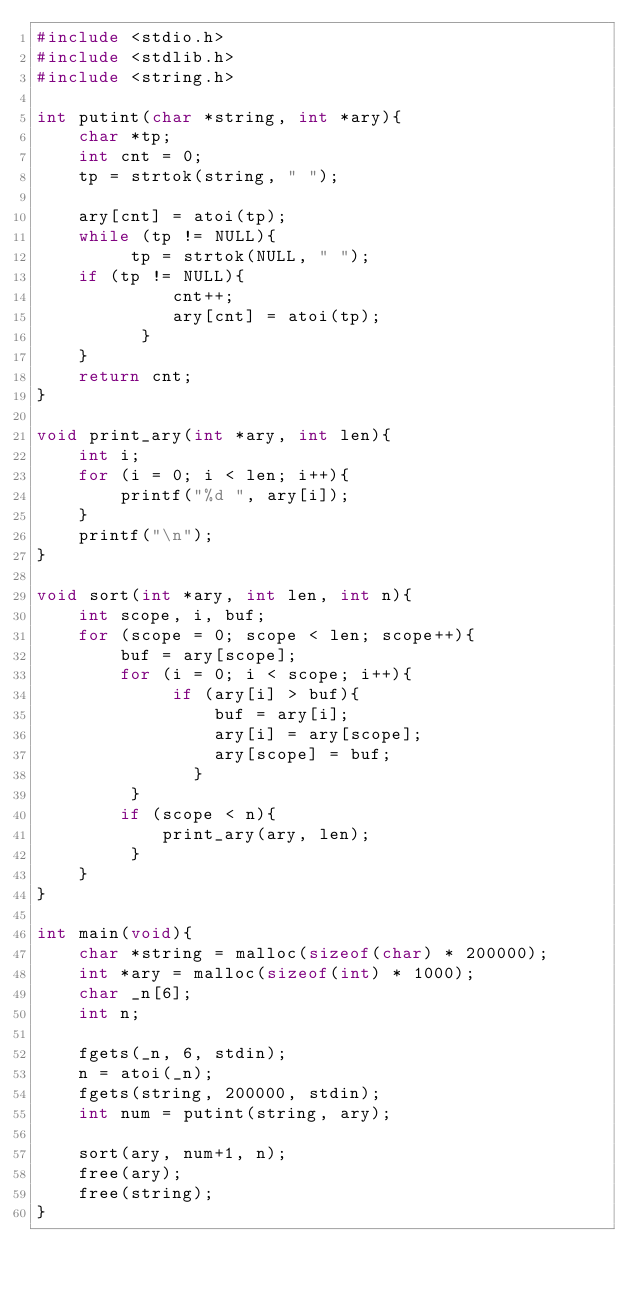<code> <loc_0><loc_0><loc_500><loc_500><_C_>#include <stdio.h>
#include <stdlib.h>
#include <string.h>

int putint(char *string, int *ary){
    char *tp;
    int cnt = 0;
    tp = strtok(string, " ");
    
    ary[cnt] = atoi(tp);
    while (tp != NULL){
         tp = strtok(NULL, " ");
	  if (tp != NULL){
             cnt++;
             ary[cnt] = atoi(tp);  
          }
    }
    return cnt;
}

void print_ary(int *ary, int len){
    int i;
    for (i = 0; i < len; i++){
        printf("%d ", ary[i]);
    }
    printf("\n");
}

void sort(int *ary, int len, int n){
    int scope, i, buf;
    for (scope = 0; scope < len; scope++){
        buf = ary[scope];
        for (i = 0; i < scope; i++){
             if (ary[i] > buf){
                 buf = ary[i];
                 ary[i] = ary[scope];
                 ary[scope] = buf; 
               }
         }
        if (scope < n){
            print_ary(ary, len);
         }
    } 
}

int main(void){
    char *string = malloc(sizeof(char) * 200000);
    int *ary = malloc(sizeof(int) * 1000);
    char _n[6];
    int n;

    fgets(_n, 6, stdin);
    n = atoi(_n);
    fgets(string, 200000, stdin);
    int num = putint(string, ary);

    sort(ary, num+1, n);
    free(ary);
    free(string);
}
</code> 